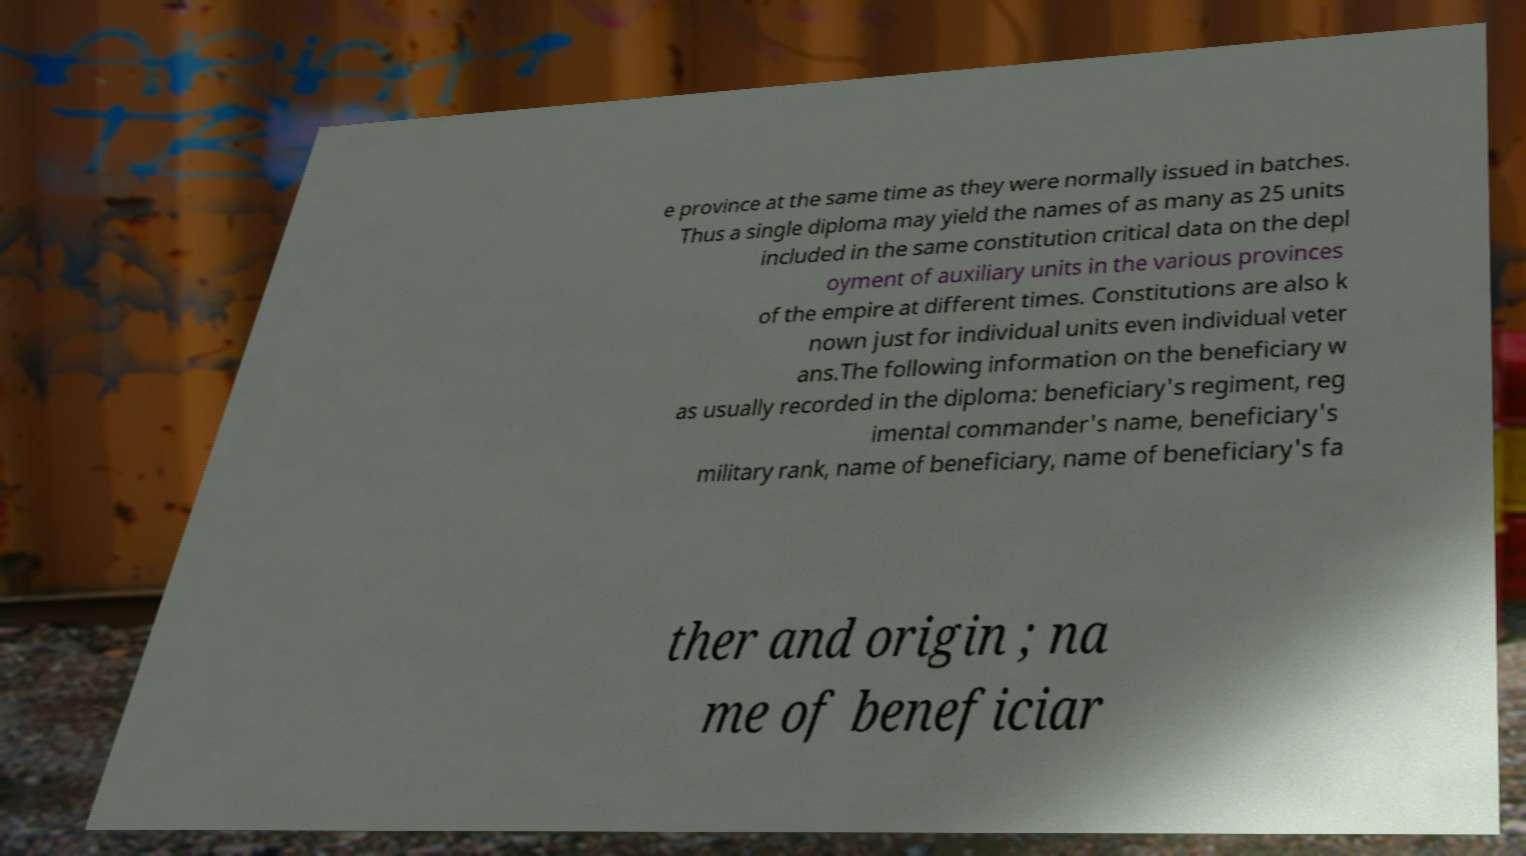Can you read and provide the text displayed in the image?This photo seems to have some interesting text. Can you extract and type it out for me? e province at the same time as they were normally issued in batches. Thus a single diploma may yield the names of as many as 25 units included in the same constitution critical data on the depl oyment of auxiliary units in the various provinces of the empire at different times. Constitutions are also k nown just for individual units even individual veter ans.The following information on the beneficiary w as usually recorded in the diploma: beneficiary's regiment, reg imental commander's name, beneficiary's military rank, name of beneficiary, name of beneficiary's fa ther and origin ; na me of beneficiar 